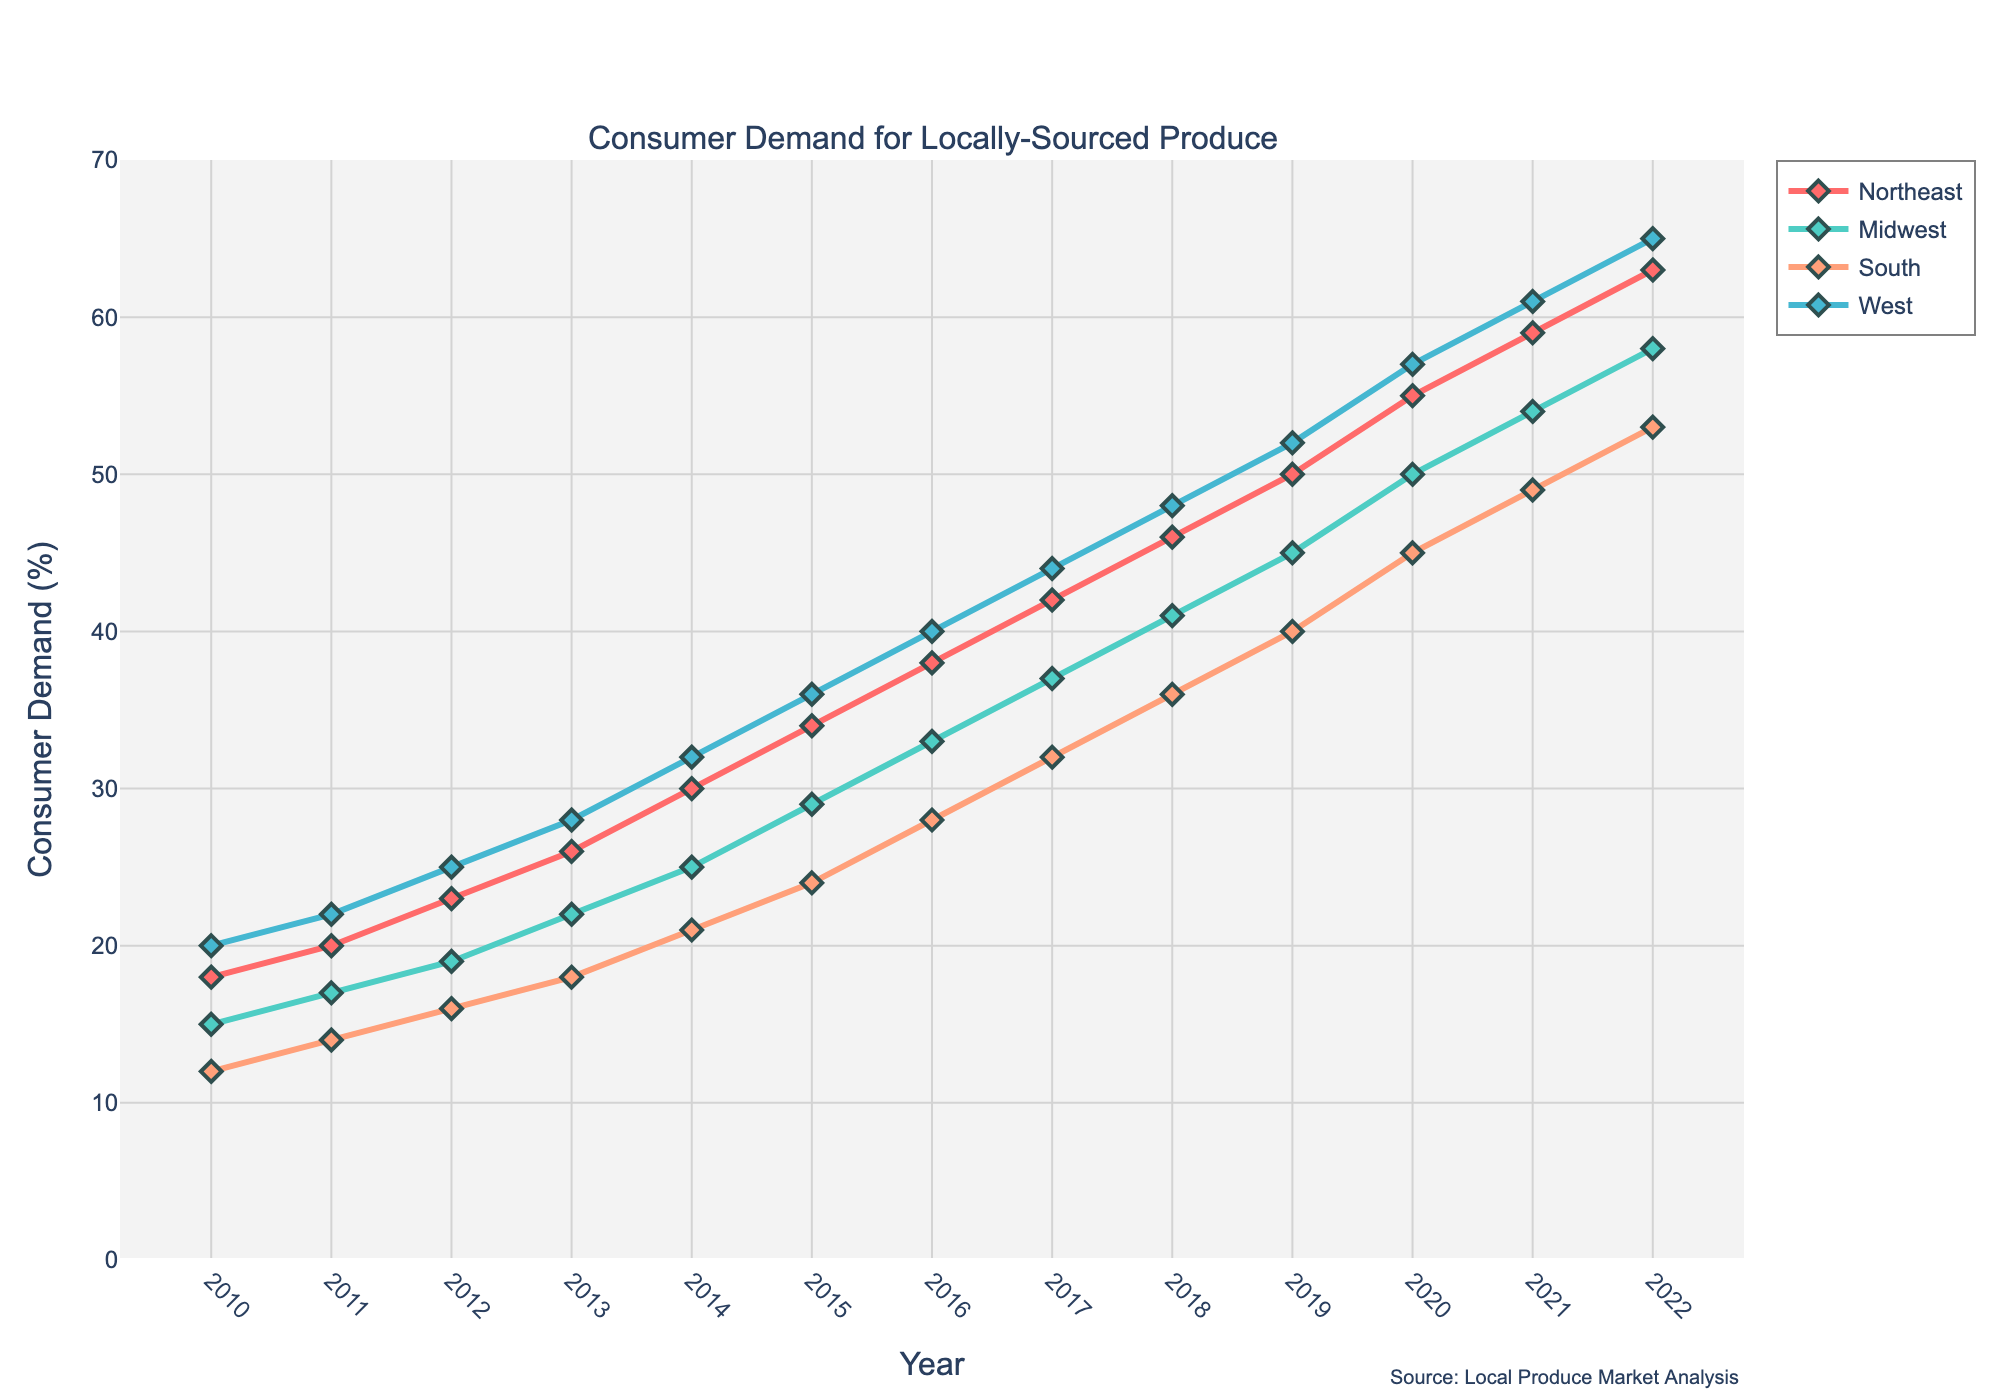What is the trend of consumer demand in the Northeast from 2010 to 2022? The graph shows a steady upward trend in the consumer demand for locally-sourced produce in the Northeast region from 2010 to 2022. The line consistently rises from 18% in 2010 to 63% in 2022.
Answer: Steady upward trend Which region had the highest consumer demand for locally-sourced produce in 2022? The graph shows that the West region had the highest consumer demand in 2022, with a value of 65%.
Answer: West In which year did the Midwest's demand first exceed 40%? By examining the line for the Midwest, we notice the first year it crosses the 40% mark is 2019, where it stands at 45%.
Answer: 2019 By how much did consumer demand in the South increase from 2010 to 2020? In 2010, the consumer demand in the South was 12%, and in 2020 it reached 45%. The increase is calculated as 45% - 12% = 33%.
Answer: 33% Compare the growth rate of consumer demand between the Northeast and the South from 2010 to 2022. In 2010, demand in the Northeast was 18% and in 2022 it was 63%, growing by 45%. For the South, demand increased from 12% in 2010 to 53% in 2022, growing by 41%.
Answer: Northeast grows faster What is the average consumer demand for locally-sourced produce in the West region from 2010 to 2022? Summing up the values from 2010 to 2022 for the West (20+22+25+28+32+36+40+44+48+52+57+61+65) gives 530%. Dividing by the number of years (13), the average is 530/13 = 40.77%.
Answer: 40.77% Which year had the highest increase in consumer demand in the Northeast? By examining the differences year over year for the Northeast, the highest increase is between 2019 (50%) and 2020 (55%), a 5% increase.
Answer: 2020 How does the 2022 consumer demand for locally-sourced produce in the South compare to that in the Midwest? In 2022, the South has a demand of 53% while the Midwest has 58%, making the Midwest's demand 5% higher.
Answer: Midwest higher by 5% Between 2013 and 2016, which region showed the most significant growth in consumer demand? The growth for each region from 2013 to 2016: Northeast (26% to 38% = 12%), Midwest (22% to 33% = 11%), South (18% to 28% = 10%), West (28% to 40% = 12%). Both Northeast and West had the most significant growth of 12%.
Answer: Northeast and West 